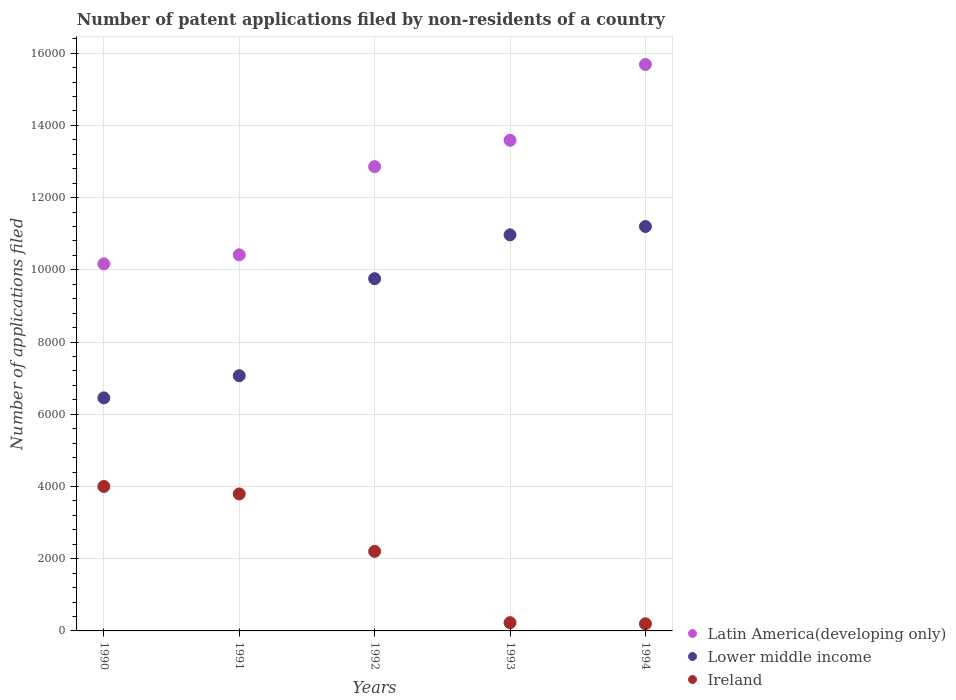Is the number of dotlines equal to the number of legend labels?
Your answer should be compact. Yes. What is the number of applications filed in Latin America(developing only) in 1993?
Give a very brief answer. 1.36e+04. Across all years, what is the maximum number of applications filed in Latin America(developing only)?
Make the answer very short. 1.57e+04. Across all years, what is the minimum number of applications filed in Ireland?
Offer a terse response. 198. In which year was the number of applications filed in Latin America(developing only) maximum?
Make the answer very short. 1994. In which year was the number of applications filed in Ireland minimum?
Keep it short and to the point. 1994. What is the total number of applications filed in Latin America(developing only) in the graph?
Make the answer very short. 6.27e+04. What is the difference between the number of applications filed in Latin America(developing only) in 1993 and that in 1994?
Your answer should be very brief. -2099. What is the difference between the number of applications filed in Ireland in 1992 and the number of applications filed in Latin America(developing only) in 1994?
Your response must be concise. -1.35e+04. What is the average number of applications filed in Ireland per year?
Offer a terse response. 2085. In the year 1991, what is the difference between the number of applications filed in Latin America(developing only) and number of applications filed in Lower middle income?
Offer a very short reply. 3347. In how many years, is the number of applications filed in Ireland greater than 12000?
Your answer should be very brief. 0. What is the ratio of the number of applications filed in Latin America(developing only) in 1992 to that in 1994?
Provide a succinct answer. 0.82. Is the number of applications filed in Lower middle income in 1990 less than that in 1994?
Your answer should be very brief. Yes. Is the difference between the number of applications filed in Latin America(developing only) in 1990 and 1991 greater than the difference between the number of applications filed in Lower middle income in 1990 and 1991?
Your answer should be very brief. Yes. What is the difference between the highest and the second highest number of applications filed in Latin America(developing only)?
Provide a succinct answer. 2099. What is the difference between the highest and the lowest number of applications filed in Lower middle income?
Offer a terse response. 4746. In how many years, is the number of applications filed in Lower middle income greater than the average number of applications filed in Lower middle income taken over all years?
Give a very brief answer. 3. Is the number of applications filed in Lower middle income strictly greater than the number of applications filed in Latin America(developing only) over the years?
Make the answer very short. No. How many dotlines are there?
Your answer should be very brief. 3. How many years are there in the graph?
Your response must be concise. 5. What is the difference between two consecutive major ticks on the Y-axis?
Your answer should be very brief. 2000. Are the values on the major ticks of Y-axis written in scientific E-notation?
Make the answer very short. No. Does the graph contain any zero values?
Give a very brief answer. No. Does the graph contain grids?
Offer a very short reply. Yes. How are the legend labels stacked?
Provide a succinct answer. Vertical. What is the title of the graph?
Make the answer very short. Number of patent applications filed by non-residents of a country. What is the label or title of the Y-axis?
Keep it short and to the point. Number of applications filed. What is the Number of applications filed of Latin America(developing only) in 1990?
Provide a succinct answer. 1.02e+04. What is the Number of applications filed in Lower middle income in 1990?
Make the answer very short. 6454. What is the Number of applications filed of Ireland in 1990?
Make the answer very short. 4001. What is the Number of applications filed in Latin America(developing only) in 1991?
Ensure brevity in your answer.  1.04e+04. What is the Number of applications filed of Lower middle income in 1991?
Offer a very short reply. 7069. What is the Number of applications filed of Ireland in 1991?
Give a very brief answer. 3794. What is the Number of applications filed in Latin America(developing only) in 1992?
Keep it short and to the point. 1.29e+04. What is the Number of applications filed in Lower middle income in 1992?
Give a very brief answer. 9755. What is the Number of applications filed in Ireland in 1992?
Make the answer very short. 2203. What is the Number of applications filed in Latin America(developing only) in 1993?
Your answer should be compact. 1.36e+04. What is the Number of applications filed in Lower middle income in 1993?
Keep it short and to the point. 1.10e+04. What is the Number of applications filed in Ireland in 1993?
Keep it short and to the point. 229. What is the Number of applications filed in Latin America(developing only) in 1994?
Your answer should be compact. 1.57e+04. What is the Number of applications filed in Lower middle income in 1994?
Make the answer very short. 1.12e+04. What is the Number of applications filed of Ireland in 1994?
Your answer should be very brief. 198. Across all years, what is the maximum Number of applications filed in Latin America(developing only)?
Give a very brief answer. 1.57e+04. Across all years, what is the maximum Number of applications filed of Lower middle income?
Your answer should be compact. 1.12e+04. Across all years, what is the maximum Number of applications filed in Ireland?
Provide a succinct answer. 4001. Across all years, what is the minimum Number of applications filed in Latin America(developing only)?
Give a very brief answer. 1.02e+04. Across all years, what is the minimum Number of applications filed in Lower middle income?
Your response must be concise. 6454. Across all years, what is the minimum Number of applications filed in Ireland?
Offer a very short reply. 198. What is the total Number of applications filed of Latin America(developing only) in the graph?
Provide a succinct answer. 6.27e+04. What is the total Number of applications filed in Lower middle income in the graph?
Provide a succinct answer. 4.54e+04. What is the total Number of applications filed of Ireland in the graph?
Your answer should be compact. 1.04e+04. What is the difference between the Number of applications filed of Latin America(developing only) in 1990 and that in 1991?
Offer a terse response. -250. What is the difference between the Number of applications filed in Lower middle income in 1990 and that in 1991?
Make the answer very short. -615. What is the difference between the Number of applications filed in Ireland in 1990 and that in 1991?
Your response must be concise. 207. What is the difference between the Number of applications filed in Latin America(developing only) in 1990 and that in 1992?
Your answer should be compact. -2693. What is the difference between the Number of applications filed of Lower middle income in 1990 and that in 1992?
Give a very brief answer. -3301. What is the difference between the Number of applications filed of Ireland in 1990 and that in 1992?
Make the answer very short. 1798. What is the difference between the Number of applications filed of Latin America(developing only) in 1990 and that in 1993?
Your response must be concise. -3421. What is the difference between the Number of applications filed in Lower middle income in 1990 and that in 1993?
Give a very brief answer. -4515. What is the difference between the Number of applications filed in Ireland in 1990 and that in 1993?
Make the answer very short. 3772. What is the difference between the Number of applications filed in Latin America(developing only) in 1990 and that in 1994?
Provide a succinct answer. -5520. What is the difference between the Number of applications filed in Lower middle income in 1990 and that in 1994?
Make the answer very short. -4746. What is the difference between the Number of applications filed of Ireland in 1990 and that in 1994?
Offer a very short reply. 3803. What is the difference between the Number of applications filed of Latin America(developing only) in 1991 and that in 1992?
Give a very brief answer. -2443. What is the difference between the Number of applications filed in Lower middle income in 1991 and that in 1992?
Give a very brief answer. -2686. What is the difference between the Number of applications filed of Ireland in 1991 and that in 1992?
Provide a short and direct response. 1591. What is the difference between the Number of applications filed of Latin America(developing only) in 1991 and that in 1993?
Your answer should be compact. -3171. What is the difference between the Number of applications filed of Lower middle income in 1991 and that in 1993?
Provide a succinct answer. -3900. What is the difference between the Number of applications filed in Ireland in 1991 and that in 1993?
Provide a short and direct response. 3565. What is the difference between the Number of applications filed in Latin America(developing only) in 1991 and that in 1994?
Provide a succinct answer. -5270. What is the difference between the Number of applications filed of Lower middle income in 1991 and that in 1994?
Make the answer very short. -4131. What is the difference between the Number of applications filed in Ireland in 1991 and that in 1994?
Make the answer very short. 3596. What is the difference between the Number of applications filed of Latin America(developing only) in 1992 and that in 1993?
Your answer should be very brief. -728. What is the difference between the Number of applications filed in Lower middle income in 1992 and that in 1993?
Keep it short and to the point. -1214. What is the difference between the Number of applications filed in Ireland in 1992 and that in 1993?
Keep it short and to the point. 1974. What is the difference between the Number of applications filed of Latin America(developing only) in 1992 and that in 1994?
Your answer should be very brief. -2827. What is the difference between the Number of applications filed in Lower middle income in 1992 and that in 1994?
Provide a succinct answer. -1445. What is the difference between the Number of applications filed of Ireland in 1992 and that in 1994?
Keep it short and to the point. 2005. What is the difference between the Number of applications filed of Latin America(developing only) in 1993 and that in 1994?
Provide a short and direct response. -2099. What is the difference between the Number of applications filed of Lower middle income in 1993 and that in 1994?
Provide a short and direct response. -231. What is the difference between the Number of applications filed of Ireland in 1993 and that in 1994?
Offer a very short reply. 31. What is the difference between the Number of applications filed in Latin America(developing only) in 1990 and the Number of applications filed in Lower middle income in 1991?
Keep it short and to the point. 3097. What is the difference between the Number of applications filed in Latin America(developing only) in 1990 and the Number of applications filed in Ireland in 1991?
Ensure brevity in your answer.  6372. What is the difference between the Number of applications filed in Lower middle income in 1990 and the Number of applications filed in Ireland in 1991?
Provide a succinct answer. 2660. What is the difference between the Number of applications filed in Latin America(developing only) in 1990 and the Number of applications filed in Lower middle income in 1992?
Your answer should be compact. 411. What is the difference between the Number of applications filed of Latin America(developing only) in 1990 and the Number of applications filed of Ireland in 1992?
Offer a very short reply. 7963. What is the difference between the Number of applications filed in Lower middle income in 1990 and the Number of applications filed in Ireland in 1992?
Your response must be concise. 4251. What is the difference between the Number of applications filed in Latin America(developing only) in 1990 and the Number of applications filed in Lower middle income in 1993?
Your response must be concise. -803. What is the difference between the Number of applications filed in Latin America(developing only) in 1990 and the Number of applications filed in Ireland in 1993?
Keep it short and to the point. 9937. What is the difference between the Number of applications filed of Lower middle income in 1990 and the Number of applications filed of Ireland in 1993?
Provide a succinct answer. 6225. What is the difference between the Number of applications filed in Latin America(developing only) in 1990 and the Number of applications filed in Lower middle income in 1994?
Offer a very short reply. -1034. What is the difference between the Number of applications filed in Latin America(developing only) in 1990 and the Number of applications filed in Ireland in 1994?
Provide a succinct answer. 9968. What is the difference between the Number of applications filed of Lower middle income in 1990 and the Number of applications filed of Ireland in 1994?
Your response must be concise. 6256. What is the difference between the Number of applications filed of Latin America(developing only) in 1991 and the Number of applications filed of Lower middle income in 1992?
Offer a terse response. 661. What is the difference between the Number of applications filed of Latin America(developing only) in 1991 and the Number of applications filed of Ireland in 1992?
Your answer should be very brief. 8213. What is the difference between the Number of applications filed of Lower middle income in 1991 and the Number of applications filed of Ireland in 1992?
Your answer should be very brief. 4866. What is the difference between the Number of applications filed in Latin America(developing only) in 1991 and the Number of applications filed in Lower middle income in 1993?
Offer a terse response. -553. What is the difference between the Number of applications filed in Latin America(developing only) in 1991 and the Number of applications filed in Ireland in 1993?
Your response must be concise. 1.02e+04. What is the difference between the Number of applications filed of Lower middle income in 1991 and the Number of applications filed of Ireland in 1993?
Your response must be concise. 6840. What is the difference between the Number of applications filed of Latin America(developing only) in 1991 and the Number of applications filed of Lower middle income in 1994?
Your answer should be very brief. -784. What is the difference between the Number of applications filed of Latin America(developing only) in 1991 and the Number of applications filed of Ireland in 1994?
Give a very brief answer. 1.02e+04. What is the difference between the Number of applications filed in Lower middle income in 1991 and the Number of applications filed in Ireland in 1994?
Ensure brevity in your answer.  6871. What is the difference between the Number of applications filed in Latin America(developing only) in 1992 and the Number of applications filed in Lower middle income in 1993?
Your answer should be compact. 1890. What is the difference between the Number of applications filed of Latin America(developing only) in 1992 and the Number of applications filed of Ireland in 1993?
Give a very brief answer. 1.26e+04. What is the difference between the Number of applications filed in Lower middle income in 1992 and the Number of applications filed in Ireland in 1993?
Keep it short and to the point. 9526. What is the difference between the Number of applications filed of Latin America(developing only) in 1992 and the Number of applications filed of Lower middle income in 1994?
Offer a very short reply. 1659. What is the difference between the Number of applications filed in Latin America(developing only) in 1992 and the Number of applications filed in Ireland in 1994?
Give a very brief answer. 1.27e+04. What is the difference between the Number of applications filed of Lower middle income in 1992 and the Number of applications filed of Ireland in 1994?
Your answer should be very brief. 9557. What is the difference between the Number of applications filed in Latin America(developing only) in 1993 and the Number of applications filed in Lower middle income in 1994?
Ensure brevity in your answer.  2387. What is the difference between the Number of applications filed in Latin America(developing only) in 1993 and the Number of applications filed in Ireland in 1994?
Provide a succinct answer. 1.34e+04. What is the difference between the Number of applications filed of Lower middle income in 1993 and the Number of applications filed of Ireland in 1994?
Offer a very short reply. 1.08e+04. What is the average Number of applications filed in Latin America(developing only) per year?
Keep it short and to the point. 1.25e+04. What is the average Number of applications filed of Lower middle income per year?
Your response must be concise. 9089.4. What is the average Number of applications filed of Ireland per year?
Your answer should be compact. 2085. In the year 1990, what is the difference between the Number of applications filed in Latin America(developing only) and Number of applications filed in Lower middle income?
Give a very brief answer. 3712. In the year 1990, what is the difference between the Number of applications filed in Latin America(developing only) and Number of applications filed in Ireland?
Give a very brief answer. 6165. In the year 1990, what is the difference between the Number of applications filed in Lower middle income and Number of applications filed in Ireland?
Keep it short and to the point. 2453. In the year 1991, what is the difference between the Number of applications filed of Latin America(developing only) and Number of applications filed of Lower middle income?
Ensure brevity in your answer.  3347. In the year 1991, what is the difference between the Number of applications filed in Latin America(developing only) and Number of applications filed in Ireland?
Ensure brevity in your answer.  6622. In the year 1991, what is the difference between the Number of applications filed in Lower middle income and Number of applications filed in Ireland?
Provide a short and direct response. 3275. In the year 1992, what is the difference between the Number of applications filed in Latin America(developing only) and Number of applications filed in Lower middle income?
Your answer should be very brief. 3104. In the year 1992, what is the difference between the Number of applications filed in Latin America(developing only) and Number of applications filed in Ireland?
Your answer should be compact. 1.07e+04. In the year 1992, what is the difference between the Number of applications filed of Lower middle income and Number of applications filed of Ireland?
Your answer should be compact. 7552. In the year 1993, what is the difference between the Number of applications filed of Latin America(developing only) and Number of applications filed of Lower middle income?
Keep it short and to the point. 2618. In the year 1993, what is the difference between the Number of applications filed in Latin America(developing only) and Number of applications filed in Ireland?
Your response must be concise. 1.34e+04. In the year 1993, what is the difference between the Number of applications filed in Lower middle income and Number of applications filed in Ireland?
Your answer should be compact. 1.07e+04. In the year 1994, what is the difference between the Number of applications filed in Latin America(developing only) and Number of applications filed in Lower middle income?
Make the answer very short. 4486. In the year 1994, what is the difference between the Number of applications filed of Latin America(developing only) and Number of applications filed of Ireland?
Provide a succinct answer. 1.55e+04. In the year 1994, what is the difference between the Number of applications filed of Lower middle income and Number of applications filed of Ireland?
Offer a very short reply. 1.10e+04. What is the ratio of the Number of applications filed of Latin America(developing only) in 1990 to that in 1991?
Keep it short and to the point. 0.98. What is the ratio of the Number of applications filed of Ireland in 1990 to that in 1991?
Offer a very short reply. 1.05. What is the ratio of the Number of applications filed in Latin America(developing only) in 1990 to that in 1992?
Give a very brief answer. 0.79. What is the ratio of the Number of applications filed of Lower middle income in 1990 to that in 1992?
Offer a terse response. 0.66. What is the ratio of the Number of applications filed in Ireland in 1990 to that in 1992?
Make the answer very short. 1.82. What is the ratio of the Number of applications filed in Latin America(developing only) in 1990 to that in 1993?
Your answer should be very brief. 0.75. What is the ratio of the Number of applications filed of Lower middle income in 1990 to that in 1993?
Offer a very short reply. 0.59. What is the ratio of the Number of applications filed in Ireland in 1990 to that in 1993?
Give a very brief answer. 17.47. What is the ratio of the Number of applications filed of Latin America(developing only) in 1990 to that in 1994?
Ensure brevity in your answer.  0.65. What is the ratio of the Number of applications filed of Lower middle income in 1990 to that in 1994?
Provide a short and direct response. 0.58. What is the ratio of the Number of applications filed of Ireland in 1990 to that in 1994?
Keep it short and to the point. 20.21. What is the ratio of the Number of applications filed of Latin America(developing only) in 1991 to that in 1992?
Offer a terse response. 0.81. What is the ratio of the Number of applications filed of Lower middle income in 1991 to that in 1992?
Offer a very short reply. 0.72. What is the ratio of the Number of applications filed in Ireland in 1991 to that in 1992?
Provide a short and direct response. 1.72. What is the ratio of the Number of applications filed in Latin America(developing only) in 1991 to that in 1993?
Your answer should be compact. 0.77. What is the ratio of the Number of applications filed of Lower middle income in 1991 to that in 1993?
Ensure brevity in your answer.  0.64. What is the ratio of the Number of applications filed in Ireland in 1991 to that in 1993?
Offer a very short reply. 16.57. What is the ratio of the Number of applications filed in Latin America(developing only) in 1991 to that in 1994?
Your answer should be very brief. 0.66. What is the ratio of the Number of applications filed in Lower middle income in 1991 to that in 1994?
Keep it short and to the point. 0.63. What is the ratio of the Number of applications filed in Ireland in 1991 to that in 1994?
Your response must be concise. 19.16. What is the ratio of the Number of applications filed in Latin America(developing only) in 1992 to that in 1993?
Offer a terse response. 0.95. What is the ratio of the Number of applications filed of Lower middle income in 1992 to that in 1993?
Your answer should be very brief. 0.89. What is the ratio of the Number of applications filed in Ireland in 1992 to that in 1993?
Your answer should be very brief. 9.62. What is the ratio of the Number of applications filed in Latin America(developing only) in 1992 to that in 1994?
Give a very brief answer. 0.82. What is the ratio of the Number of applications filed of Lower middle income in 1992 to that in 1994?
Ensure brevity in your answer.  0.87. What is the ratio of the Number of applications filed in Ireland in 1992 to that in 1994?
Provide a succinct answer. 11.13. What is the ratio of the Number of applications filed of Latin America(developing only) in 1993 to that in 1994?
Keep it short and to the point. 0.87. What is the ratio of the Number of applications filed in Lower middle income in 1993 to that in 1994?
Give a very brief answer. 0.98. What is the ratio of the Number of applications filed of Ireland in 1993 to that in 1994?
Provide a short and direct response. 1.16. What is the difference between the highest and the second highest Number of applications filed in Latin America(developing only)?
Provide a short and direct response. 2099. What is the difference between the highest and the second highest Number of applications filed of Lower middle income?
Your response must be concise. 231. What is the difference between the highest and the second highest Number of applications filed of Ireland?
Provide a short and direct response. 207. What is the difference between the highest and the lowest Number of applications filed of Latin America(developing only)?
Provide a short and direct response. 5520. What is the difference between the highest and the lowest Number of applications filed in Lower middle income?
Provide a succinct answer. 4746. What is the difference between the highest and the lowest Number of applications filed in Ireland?
Ensure brevity in your answer.  3803. 